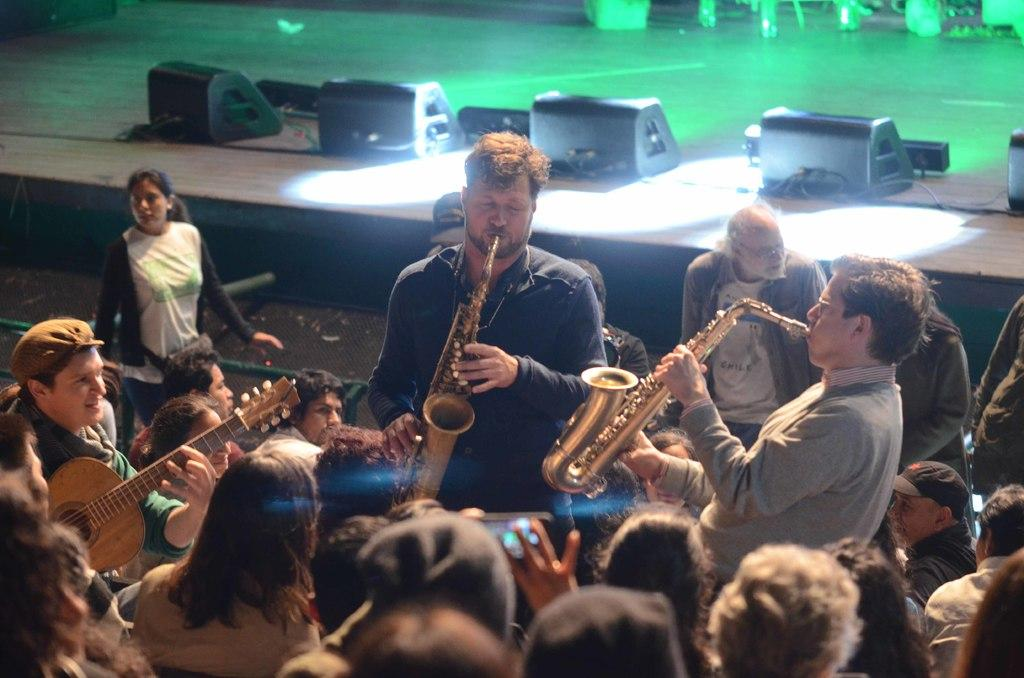How many people are in the picture? There is a group of people in the picture. What are the people in the picture doing? The people are playing different musical instruments. How many trucks can be seen in the picture? There are no trucks present in the picture; it features a group of people playing musical instruments. 